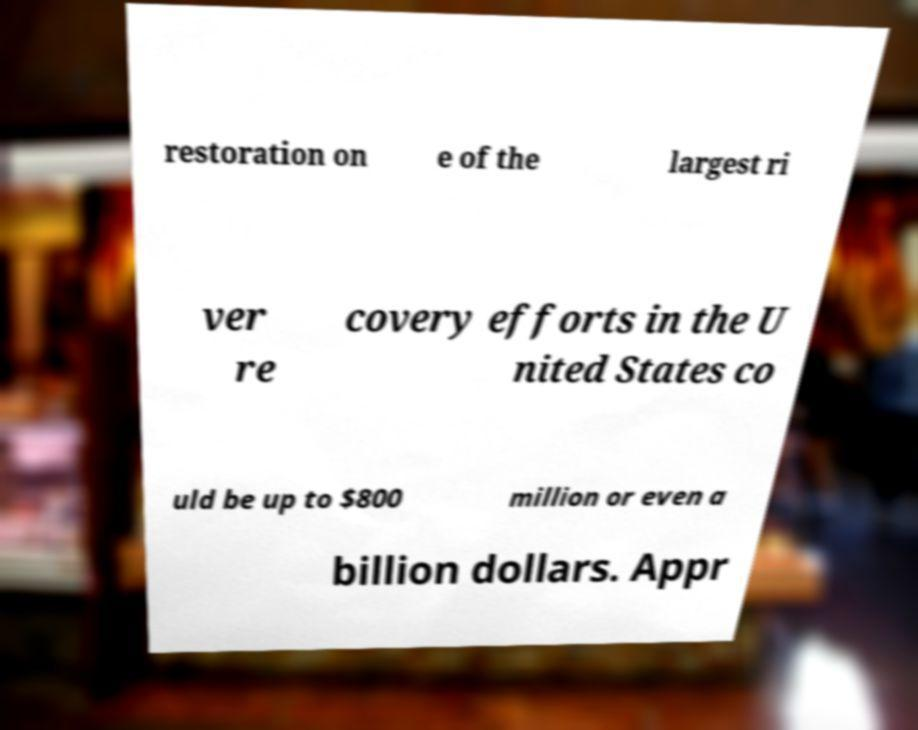I need the written content from this picture converted into text. Can you do that? restoration on e of the largest ri ver re covery efforts in the U nited States co uld be up to $800 million or even a billion dollars. Appr 